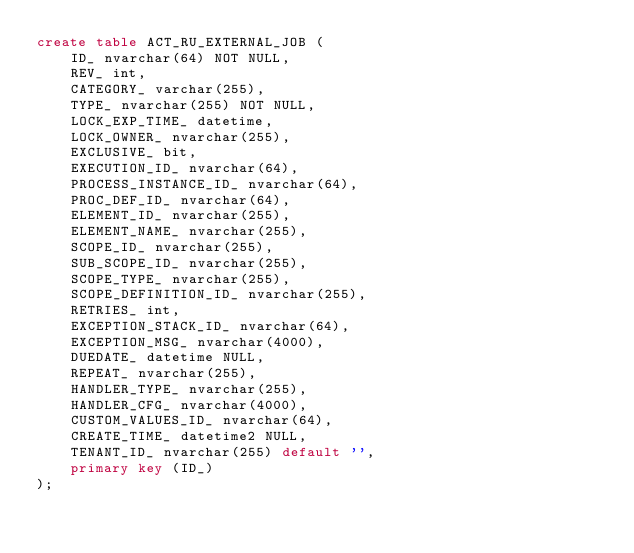<code> <loc_0><loc_0><loc_500><loc_500><_SQL_>create table ACT_RU_EXTERNAL_JOB (
    ID_ nvarchar(64) NOT NULL,
    REV_ int,
    CATEGORY_ varchar(255),
    TYPE_ nvarchar(255) NOT NULL,
    LOCK_EXP_TIME_ datetime,
    LOCK_OWNER_ nvarchar(255),
    EXCLUSIVE_ bit,
    EXECUTION_ID_ nvarchar(64),
    PROCESS_INSTANCE_ID_ nvarchar(64),
    PROC_DEF_ID_ nvarchar(64),
    ELEMENT_ID_ nvarchar(255),
    ELEMENT_NAME_ nvarchar(255),
    SCOPE_ID_ nvarchar(255),
    SUB_SCOPE_ID_ nvarchar(255),
    SCOPE_TYPE_ nvarchar(255),
    SCOPE_DEFINITION_ID_ nvarchar(255),
    RETRIES_ int,
    EXCEPTION_STACK_ID_ nvarchar(64),
    EXCEPTION_MSG_ nvarchar(4000),
    DUEDATE_ datetime NULL,
    REPEAT_ nvarchar(255),
    HANDLER_TYPE_ nvarchar(255),
    HANDLER_CFG_ nvarchar(4000),
    CUSTOM_VALUES_ID_ nvarchar(64),
    CREATE_TIME_ datetime2 NULL,
    TENANT_ID_ nvarchar(255) default '',
    primary key (ID_)
);
</code> 